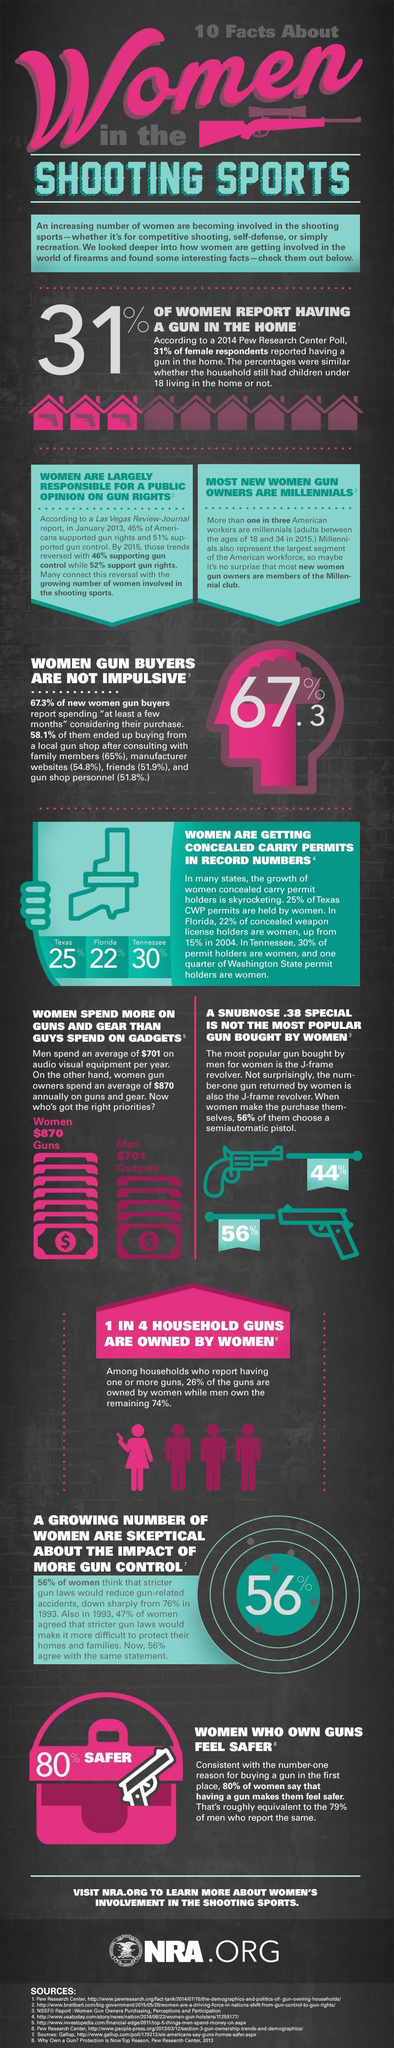Which states have less than 29% of women getting concealed carry permits
Answer the question with a short phrase. Texas, Florida What % of women gun buyers are impulsive 32.7 